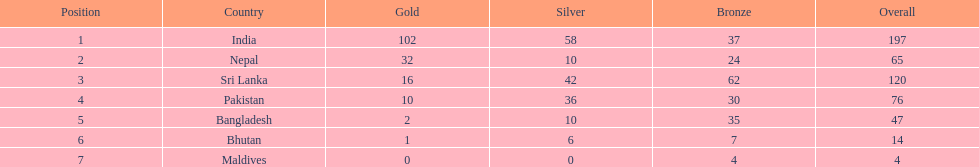Help me parse the entirety of this table. {'header': ['Position', 'Country', 'Gold', 'Silver', 'Bronze', 'Overall'], 'rows': [['1', 'India', '102', '58', '37', '197'], ['2', 'Nepal', '32', '10', '24', '65'], ['3', 'Sri Lanka', '16', '42', '62', '120'], ['4', 'Pakistan', '10', '36', '30', '76'], ['5', 'Bangladesh', '2', '10', '35', '47'], ['6', 'Bhutan', '1', '6', '7', '14'], ['7', 'Maldives', '0', '0', '4', '4']]} How many more gold medals has nepal won than pakistan? 22. 